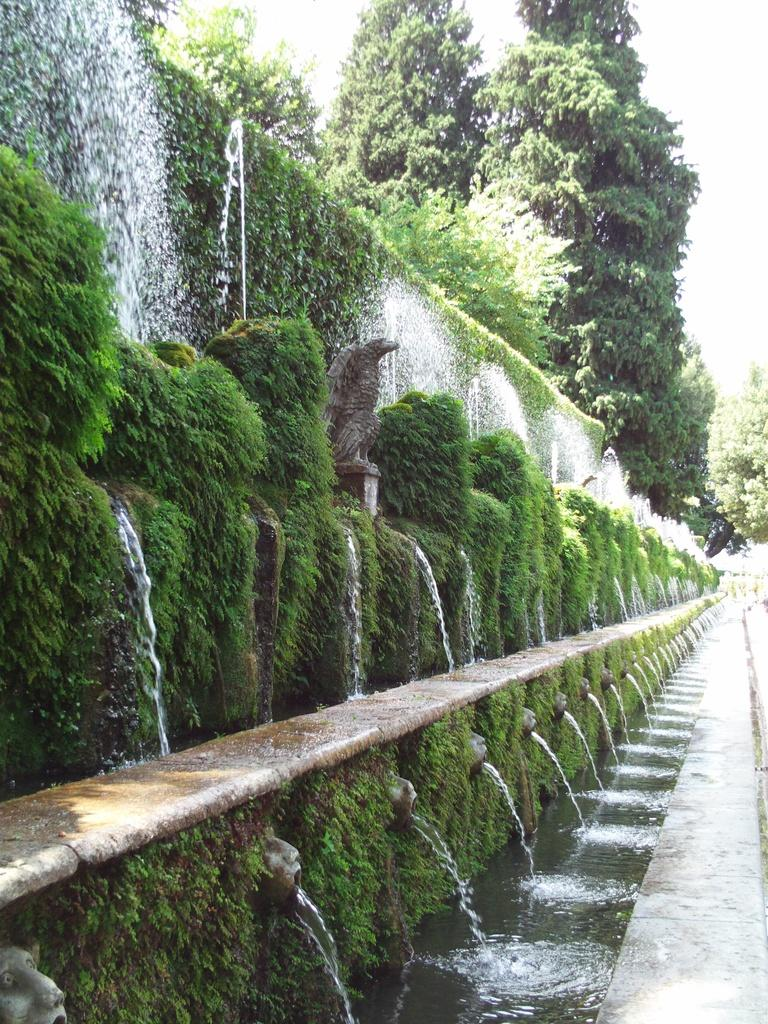What type of vegetation is present in the image? There are many trees and plants in the image. Can you describe any man-made structures in the image? Yes, there is a wall in the image. What type of punishment is being carried out in the image? There is no indication of any punishment being carried out in the image; it primarily features trees, plants, and a wall. What type of animal can be seen interacting with the plants in the image? There are no animals present in the image; it only features trees, plants, and a wall. 